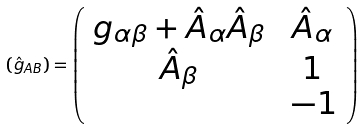Convert formula to latex. <formula><loc_0><loc_0><loc_500><loc_500>\left ( \hat { g } _ { A B } \right ) = \left ( \begin{array} { c c } g _ { \alpha \beta } + \hat { A } _ { \alpha } \hat { A } _ { \beta } \, & \, \hat { A } _ { \alpha } \, \\ \hat { A } _ { \beta } \, & \, 1 \, \\ \, & \, - 1 \end{array} \right )</formula> 